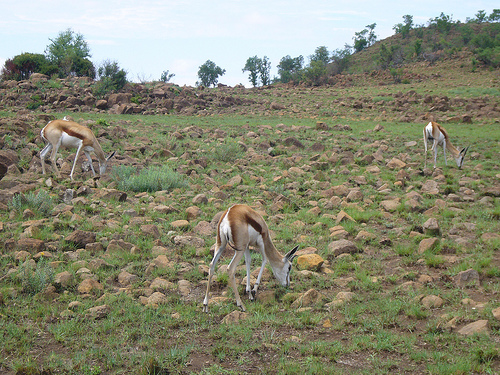<image>
Can you confirm if the tree is behind the deer? Yes. From this viewpoint, the tree is positioned behind the deer, with the deer partially or fully occluding the tree. 